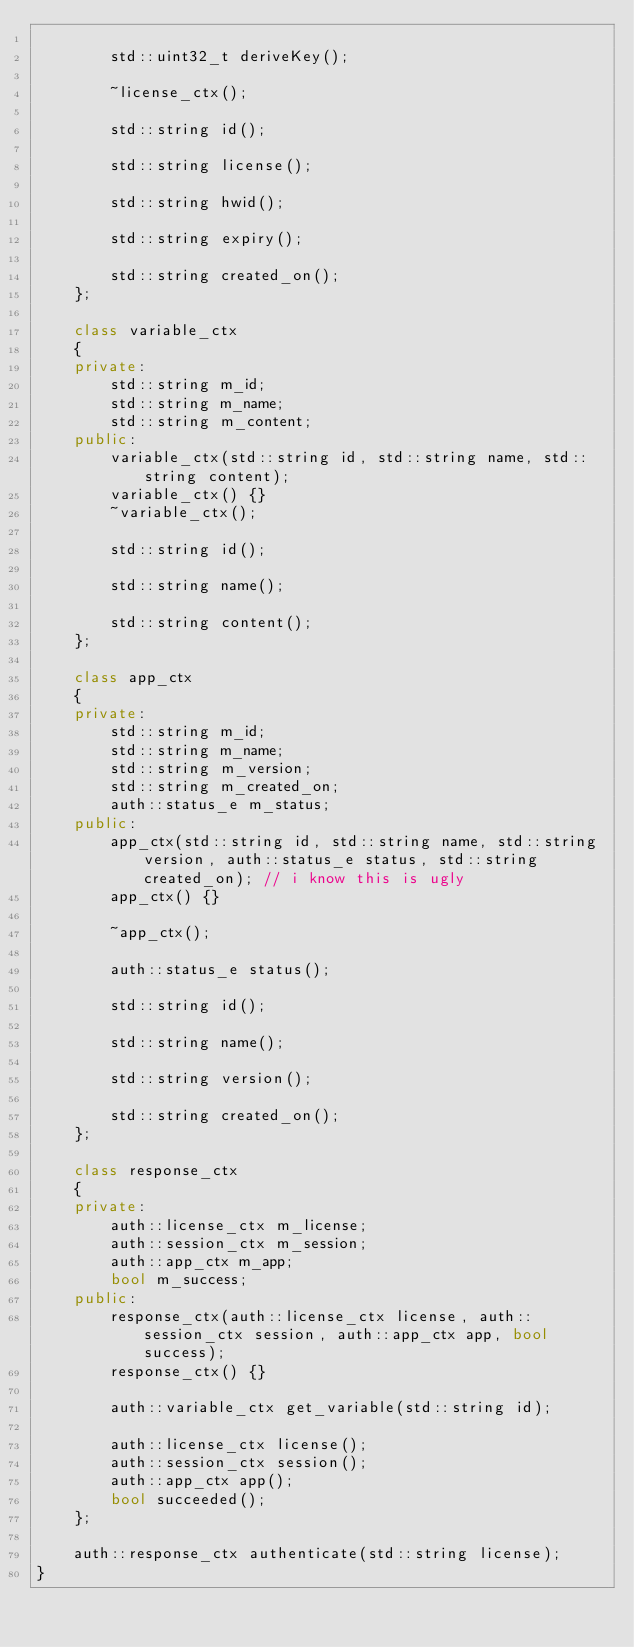<code> <loc_0><loc_0><loc_500><loc_500><_C++_>
		std::uint32_t deriveKey();

		~license_ctx();

		std::string id();

		std::string license();

		std::string hwid();

		std::string expiry();

		std::string created_on();
	};

	class variable_ctx
	{
	private:
		std::string m_id;
		std::string m_name;
		std::string m_content;
	public:
		variable_ctx(std::string id, std::string name, std::string content);
		variable_ctx() {}
		~variable_ctx();

		std::string id();

		std::string name();

		std::string content();
	};

	class app_ctx
	{
	private:
		std::string m_id;
		std::string m_name;
		std::string m_version; 
		std::string m_created_on;
		auth::status_e m_status;
	public:
		app_ctx(std::string id, std::string name, std::string version, auth::status_e status, std::string created_on); // i know this is ugly
		app_ctx() {}

		~app_ctx();

		auth::status_e status();

		std::string id();

		std::string name();

		std::string version();

		std::string created_on();
	};

	class response_ctx
	{
	private:
		auth::license_ctx m_license;
		auth::session_ctx m_session;
		auth::app_ctx m_app;
		bool m_success;
	public:
		response_ctx(auth::license_ctx license, auth::session_ctx session, auth::app_ctx app, bool success);
		response_ctx() {}

		auth::variable_ctx get_variable(std::string id);

		auth::license_ctx license();
		auth::session_ctx session();
		auth::app_ctx app();
		bool succeeded();
	};

	auth::response_ctx authenticate(std::string license);
}</code> 